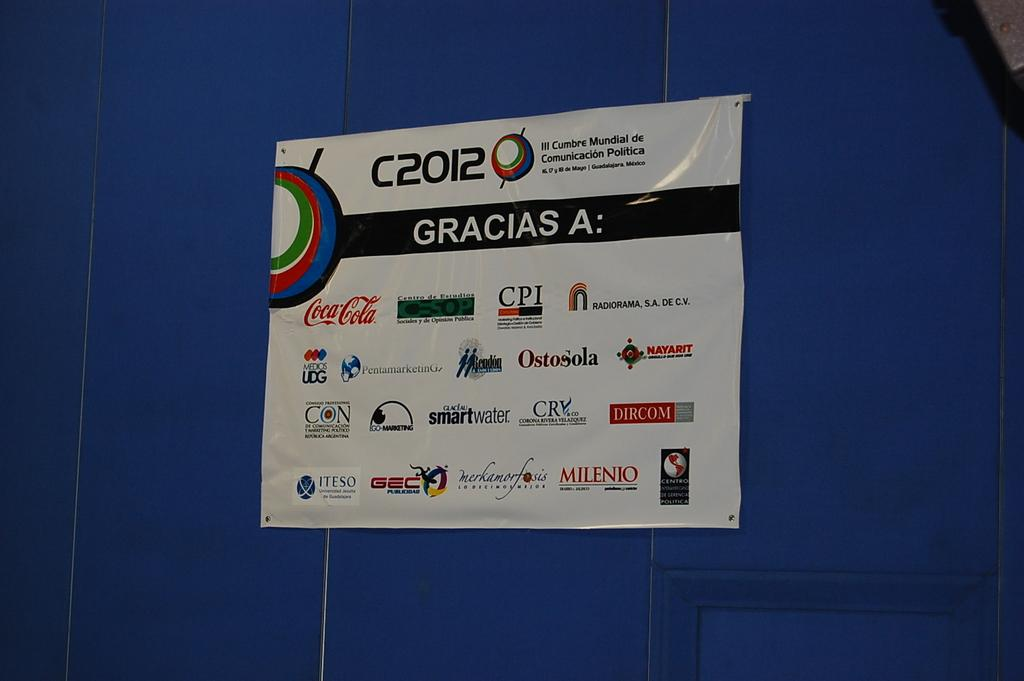<image>
Provide a brief description of the given image. a gracias sign that is white on a blue background 